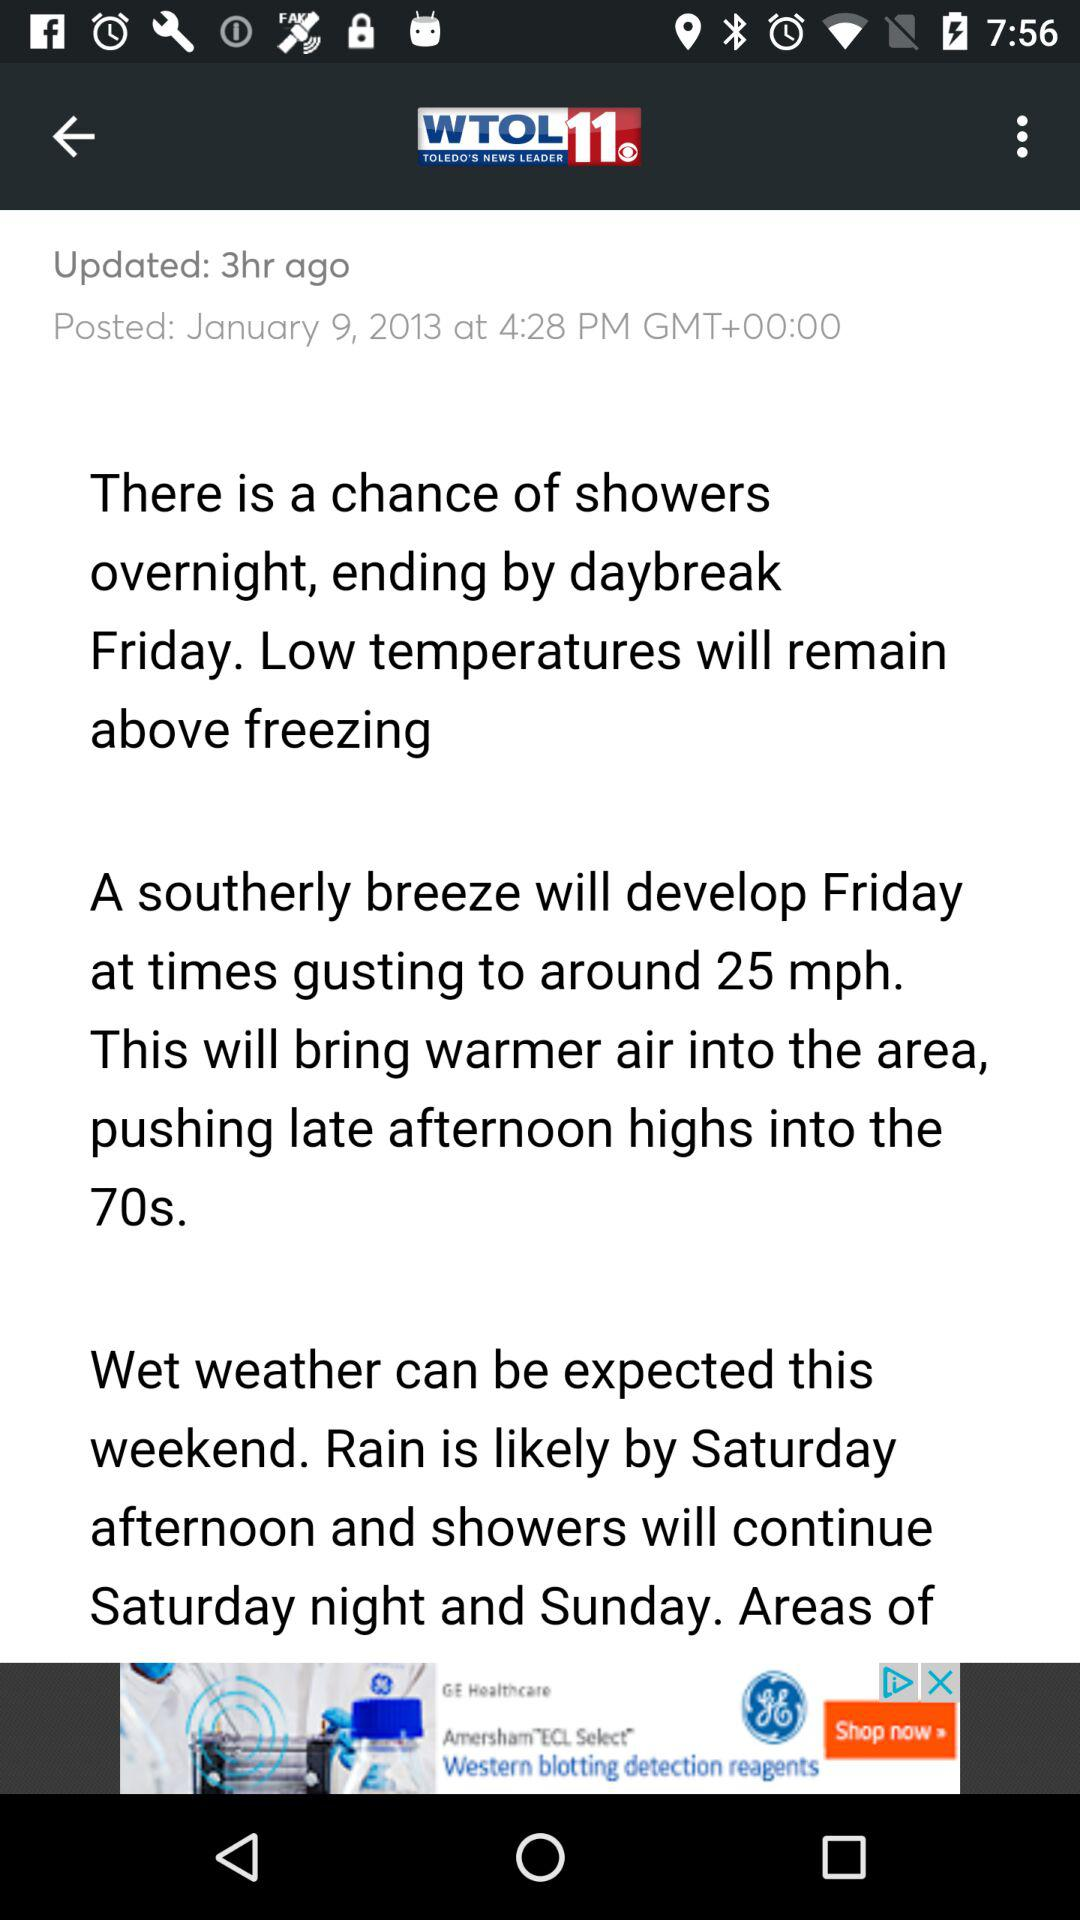How many hours ago was the news updated? The news was updated 3 hours ago. 